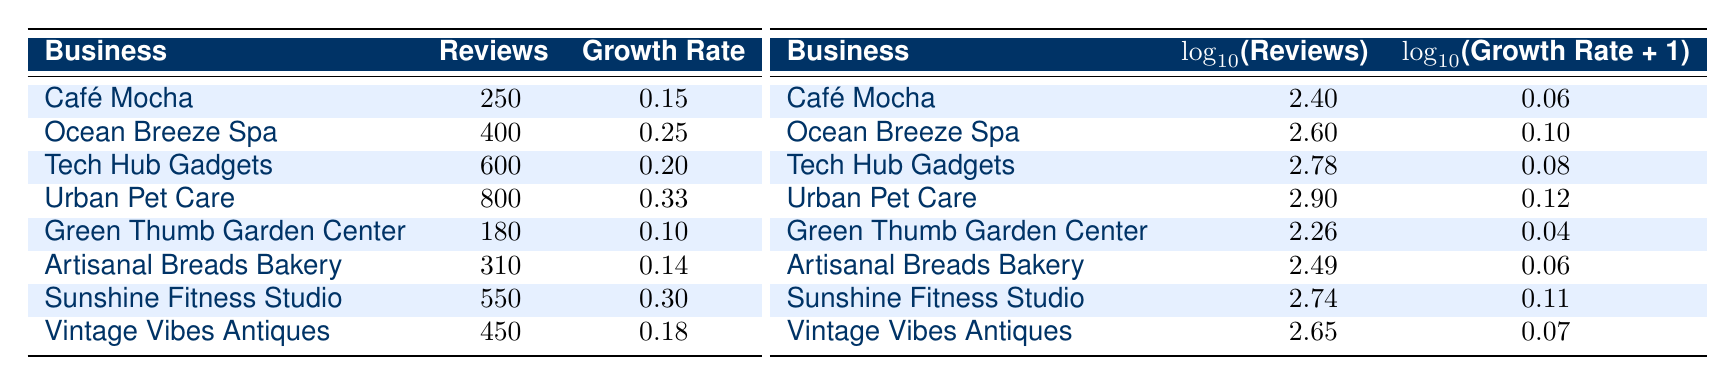What business had the highest number of reviews in 2023? Looking through the table, "Urban Pet Care" has 800 reviews listed for the year 2023, which is higher than any other business for that year.
Answer: Urban Pet Care What is the growth rate for "Café Mocha"? The "Café Mocha" entry in the table shows a growth rate of 0.15, which can be directly retrieved from the corresponding row.
Answer: 0.15 Which business had the lowest growth rate in 2020? The entry for "Green Thumb Garden Center" indicates a growth rate of 0.10, which is lower than "Café Mocha" at 0.15. Therefore, it is the lowest for that year.
Answer: Green Thumb Garden Center What is the average growth rate of all businesses in 2021? The growth rates for 2021 are 0.25 (Ocean Breeze Spa) and 0.14 (Artisanal Breads Bakery). Summing these gives 0.25 + 0.14 = 0.39. Dividing by 2 (the number of businesses) gives an average of 0.39 / 2 = 0.195.
Answer: 0.195 Is the growth rate for "Sunshine Fitness Studio" higher than that of "Vintage Vibes Antiques"? "Sunshine Fitness Studio" has a growth rate of 0.30, while "Vintage Vibes Antiques" has a growth rate of 0.18. Since 0.30 is greater than 0.18, the statement is true.
Answer: Yes What is the difference in the number of reviews between "Tech Hub Gadgets" and "Artisanal Breads Bakery"? "Tech Hub Gadgets" has 600 reviews, and "Artisanal Breads Bakery" has 310 reviews. The difference is calculated as 600 - 310 = 290.
Answer: 290 Which business had more than 500 reviews and also a growth rate higher than 0.20? "Sunshine Fitness Studio" has 550 reviews and a growth rate of 0.30, which fits both conditions. "Tech Hub Gadgets" also has 600 reviews but a growth rate of 0.20, which does not meet the criteria for growth rate.
Answer: Sunshine Fitness Studio What is the log of the reviews for "Ocean Breeze Spa"? The table shows a log of the number of reviews for "Ocean Breeze Spa" as 2.60, which is a direct extraction from the corresponding entry in the log table.
Answer: 2.60 